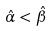<formula> <loc_0><loc_0><loc_500><loc_500>\hat { \alpha } < \hat { \beta }</formula> 